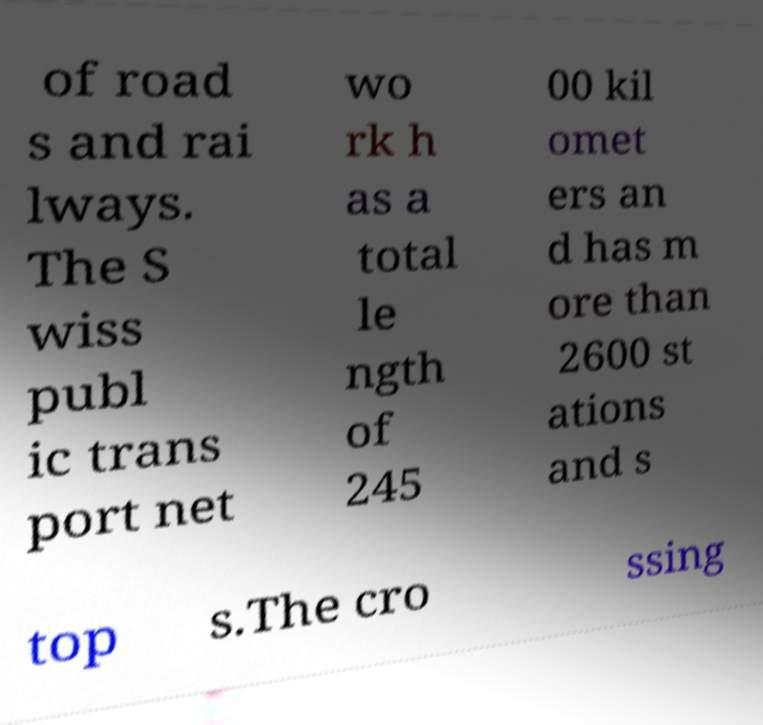What messages or text are displayed in this image? I need them in a readable, typed format. of road s and rai lways. The S wiss publ ic trans port net wo rk h as a total le ngth of 245 00 kil omet ers an d has m ore than 2600 st ations and s top s.The cro ssing 